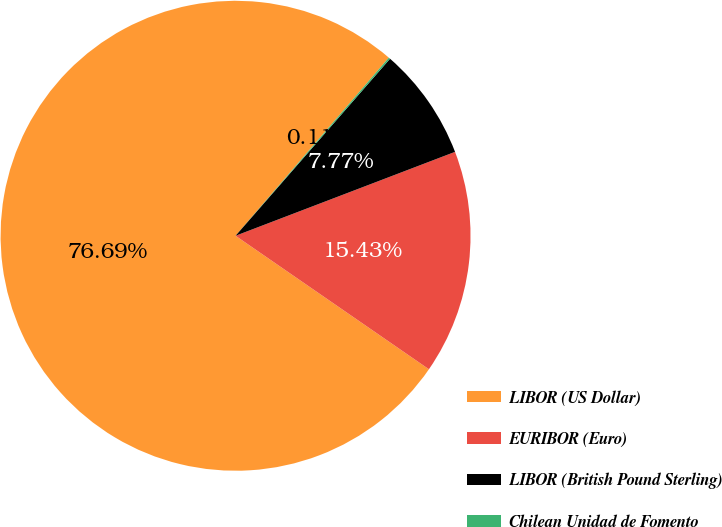<chart> <loc_0><loc_0><loc_500><loc_500><pie_chart><fcel>LIBOR (US Dollar)<fcel>EURIBOR (Euro)<fcel>LIBOR (British Pound Sterling)<fcel>Chilean Unidad de Fomento<nl><fcel>76.7%<fcel>15.43%<fcel>7.77%<fcel>0.11%<nl></chart> 